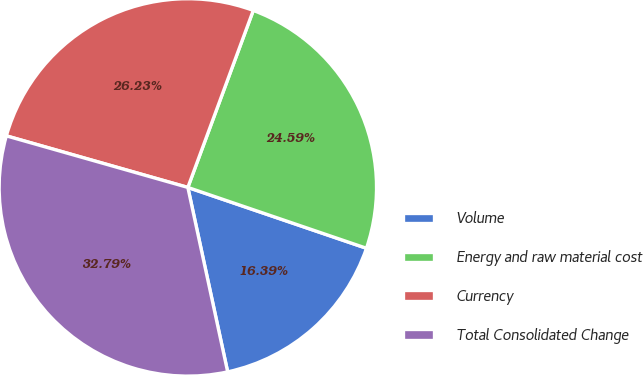Convert chart to OTSL. <chart><loc_0><loc_0><loc_500><loc_500><pie_chart><fcel>Volume<fcel>Energy and raw material cost<fcel>Currency<fcel>Total Consolidated Change<nl><fcel>16.39%<fcel>24.59%<fcel>26.23%<fcel>32.79%<nl></chart> 